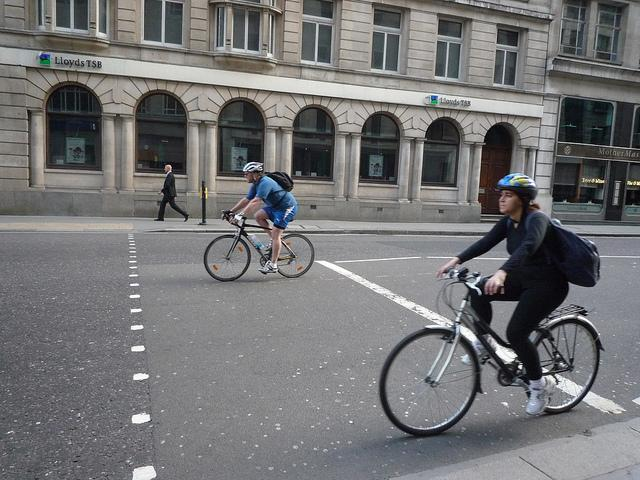When did two companies merge into this one bank?

Choices:
A) 2018
B) 1981
C) 2008
D) 1995 1995 